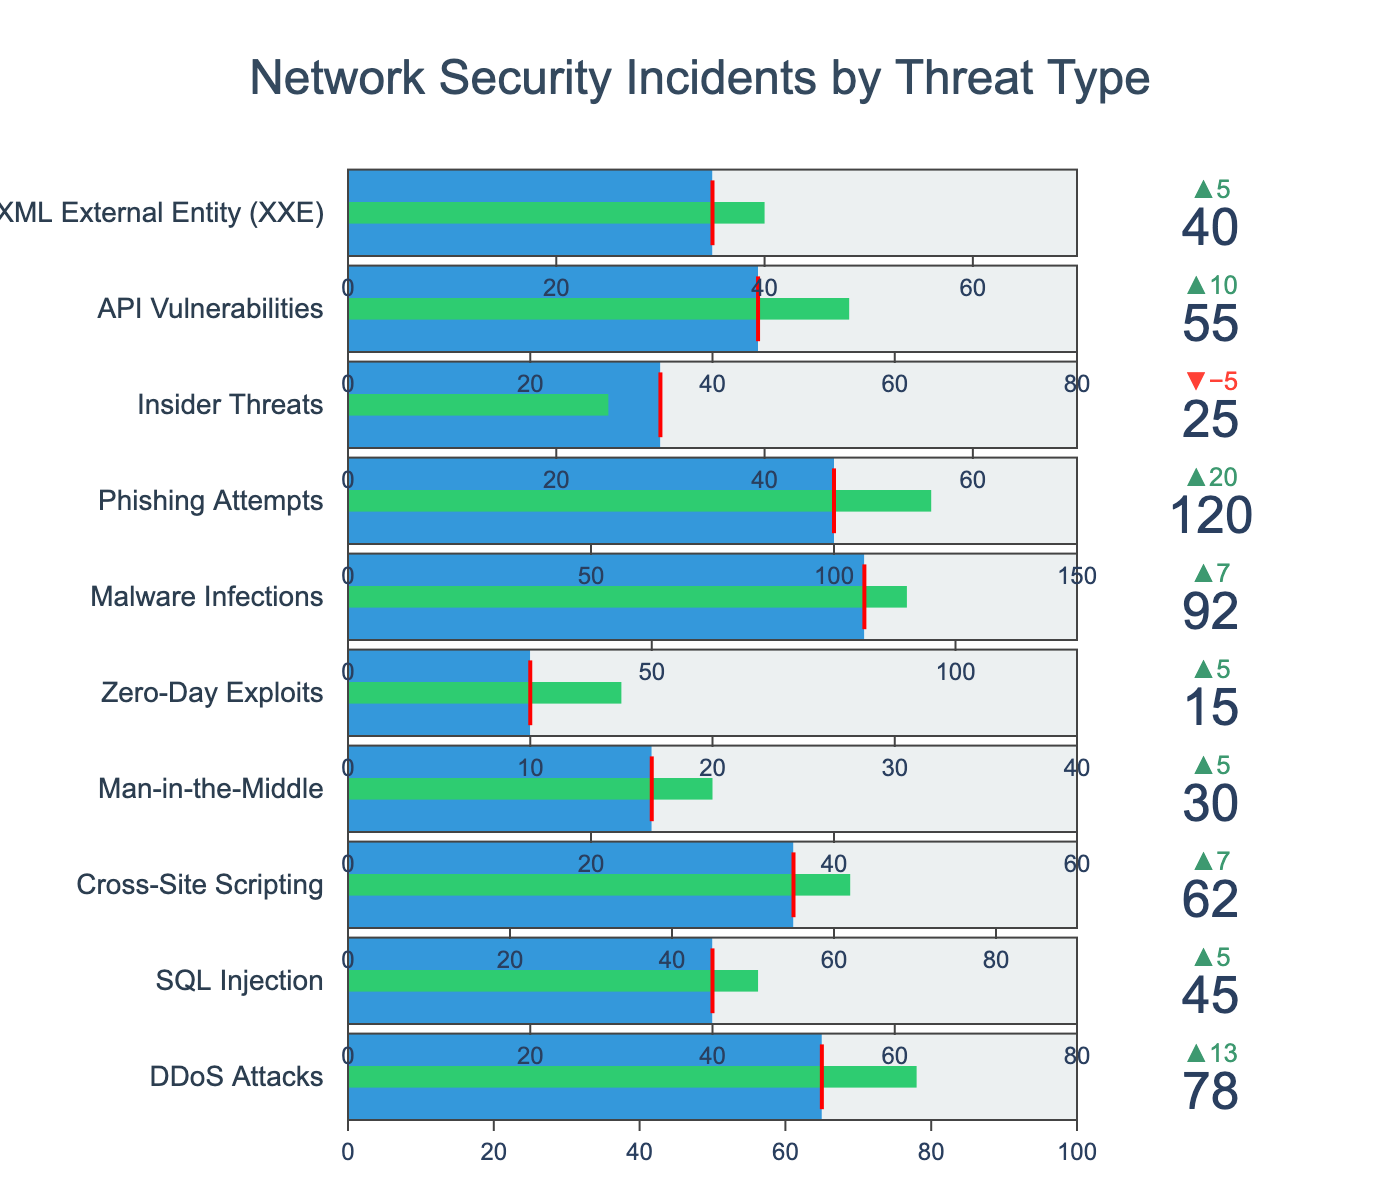What is the benchmark value for SQL Injection incidents? The benchmark value for SQL Injection incidents can be found directly on the chart where the benchmark threshold is indicated.
Answer: 40 How many more Malware Infections are there compared to the benchmark? To find the difference, subtract the benchmark value for Malware Infections from the actual number of Malware Infections: 92 - 85 = 7.
Answer: 7 Which threat type has the highest number of incidents? To determine this, examine the number of incidents reported for each threat type, and identify the highest one, which is Phishing Attempts with 120 incidents.
Answer: Phishing Attempts What is the difference between the maximum and the benchmark values for Zero-Day Exploits? Subtract the benchmark value for Zero-Day Exploits from its maximum value: 40 - 10 = 30.
Answer: 30 How does the number of API Vulnerabilities incidents compare to its benchmark? The number of API Vulnerabilities incidents (55) is higher than its benchmark (45).
Answer: Higher Which threat type has the largest margin above its benchmark? Calculate the margin for each threat type (Incidents - Benchmark), and identify the one with the highest margin: Phishing Attempts (120 - 100 = 20).
Answer: Phishing Attempts What is the average value of the benchmark for all threat types? Add up all the benchmark values: 65 + 40 + 55 + 25 + 10 + 85 + 100 + 30 + 45 + 35 = 490. Divide by the number of threat types (10): 490 / 10 = 49.
Answer: 49 Are there any threat types where the incidents are below their benchmark? Yes, Insider Threats have fewer incidents (25) than their benchmark (30).
Answer: Yes (Insider Threats) Which threats have their actual incidents equal to the maximum value on the chart? Compare the incidents to the maximum values; none of the threat types have incidents equal to the maximum values given in the chart.
Answer: None What does the red line indicate in the bullet chart? The red line indicates the benchmark value for each threat type, which serves as a reference point to compare the actual number of incidents.
Answer: Benchmark value 